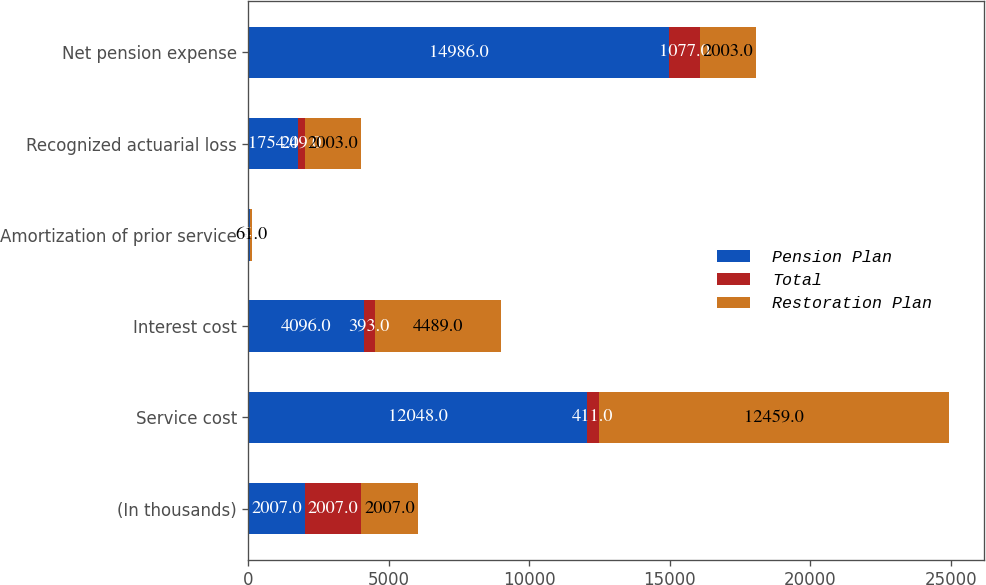Convert chart. <chart><loc_0><loc_0><loc_500><loc_500><stacked_bar_chart><ecel><fcel>(In thousands)<fcel>Service cost<fcel>Interest cost<fcel>Amortization of prior service<fcel>Recognized actuarial loss<fcel>Net pension expense<nl><fcel>Pension Plan<fcel>2007<fcel>12048<fcel>4096<fcel>37<fcel>1754<fcel>14986<nl><fcel>Total<fcel>2007<fcel>411<fcel>393<fcel>24<fcel>249<fcel>1077<nl><fcel>Restoration Plan<fcel>2007<fcel>12459<fcel>4489<fcel>61<fcel>2003<fcel>2003<nl></chart> 